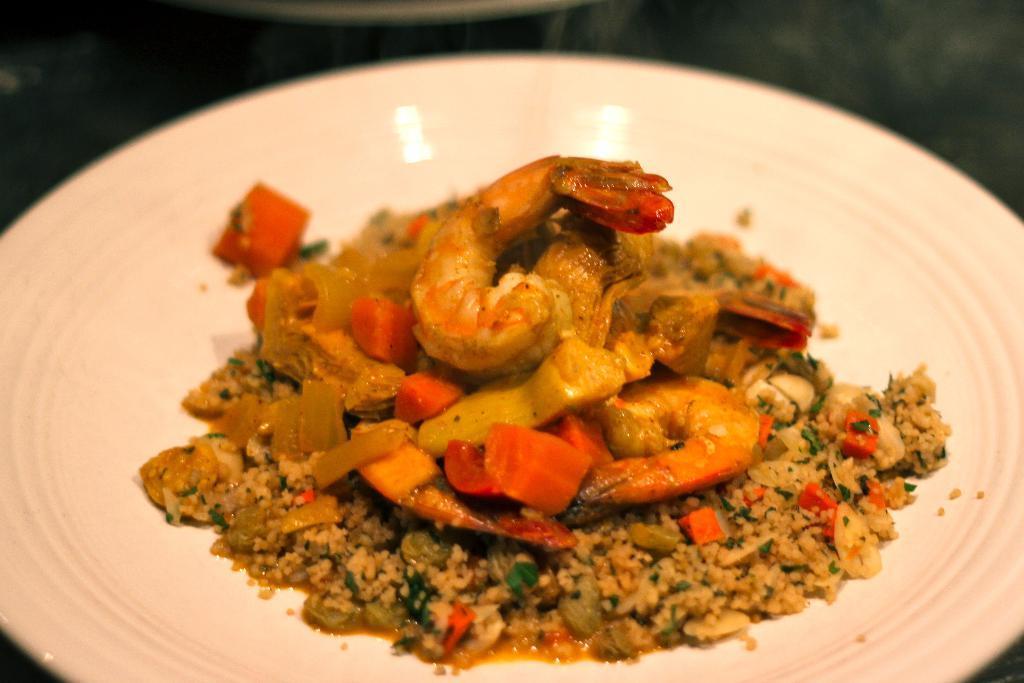In one or two sentences, can you explain what this image depicts? The picture consists of a plate served with food. At the top it is blurred. 